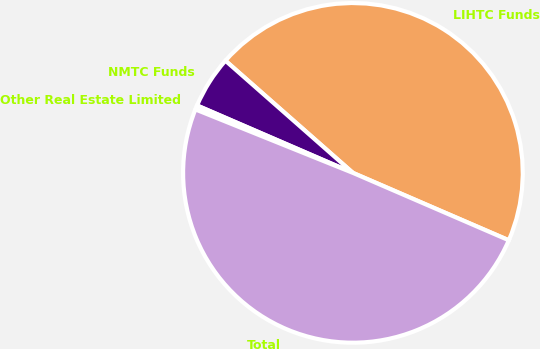Convert chart. <chart><loc_0><loc_0><loc_500><loc_500><pie_chart><fcel>LIHTC Funds<fcel>NMTC Funds<fcel>Other Real Estate Limited<fcel>Total<nl><fcel>45.01%<fcel>4.99%<fcel>0.4%<fcel>49.6%<nl></chart> 